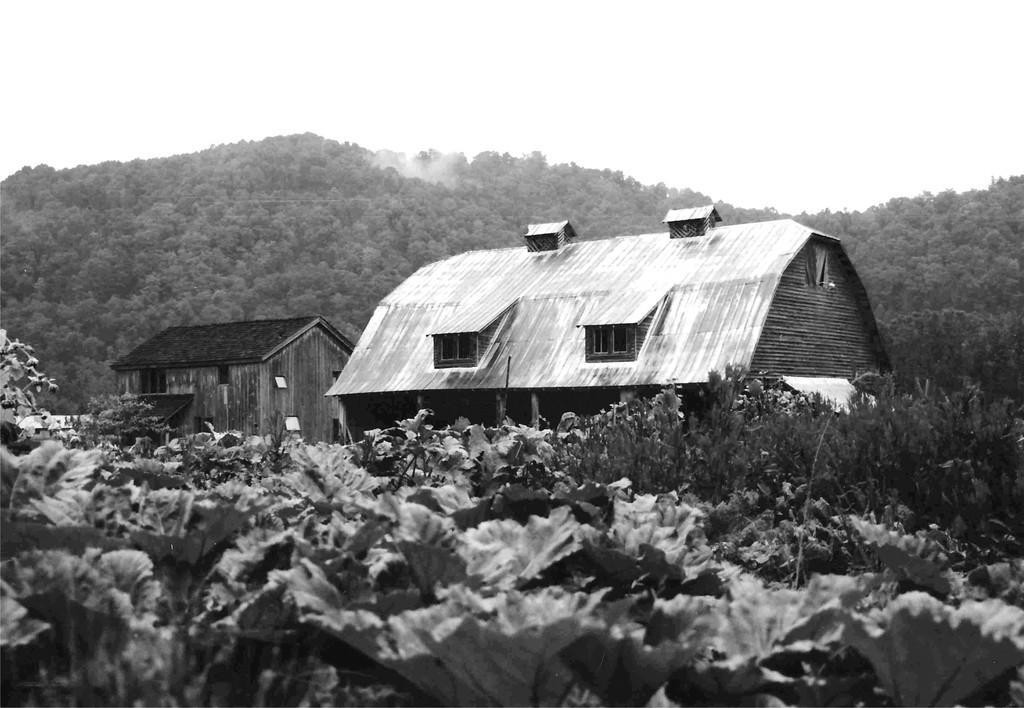Can you describe this image briefly? This picture is in black and white. In the center, there are two houses constructed with the wood. At the bottom, there are plants. In the background there are hills with trees. On the top, there is a sky. 